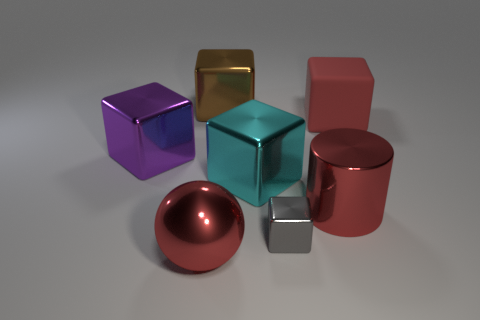There is a ball that is made of the same material as the brown block; what color is it?
Offer a terse response. Red. How many gray blocks have the same size as the purple thing?
Provide a succinct answer. 0. What number of cyan things are either large balls or metal cubes?
Keep it short and to the point. 1. How many objects are big metal things or big cubes that are in front of the brown shiny cube?
Make the answer very short. 6. There is a block that is in front of the red cylinder; what is it made of?
Offer a terse response. Metal. What is the shape of the purple metallic thing that is the same size as the brown thing?
Offer a terse response. Cube. Are there any big metal objects that have the same shape as the rubber thing?
Your answer should be very brief. Yes. Is the material of the large brown thing the same as the big red object that is behind the cyan thing?
Ensure brevity in your answer.  No. What material is the red cylinder behind the red shiny object left of the big brown metal thing made of?
Offer a terse response. Metal. Are there more large cylinders behind the tiny gray metal object than purple matte cubes?
Your answer should be very brief. Yes. 